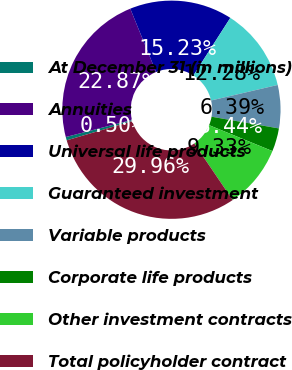Convert chart. <chart><loc_0><loc_0><loc_500><loc_500><pie_chart><fcel>At December 31 (in millions)<fcel>Annuities<fcel>Universal life products<fcel>Guaranteed investment<fcel>Variable products<fcel>Corporate life products<fcel>Other investment contracts<fcel>Total policyholder contract<nl><fcel>0.5%<fcel>22.87%<fcel>15.23%<fcel>12.28%<fcel>6.39%<fcel>3.44%<fcel>9.33%<fcel>29.96%<nl></chart> 